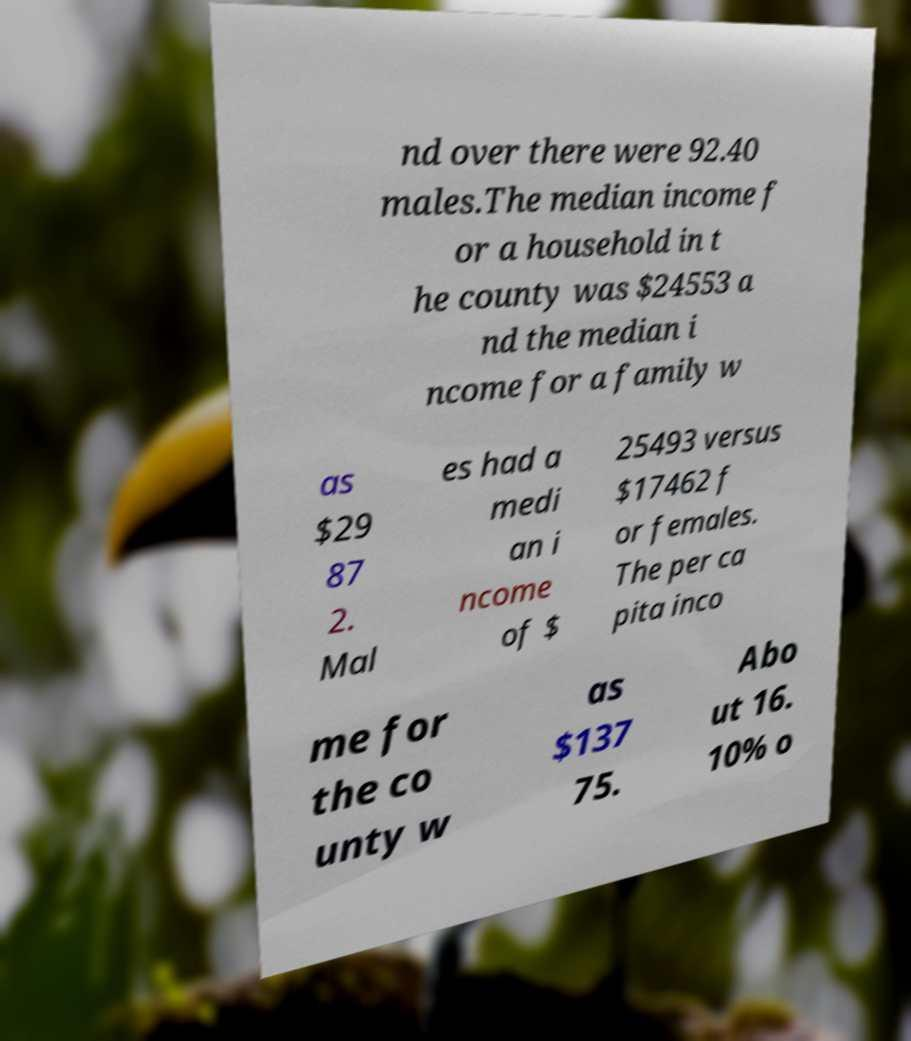Can you accurately transcribe the text from the provided image for me? nd over there were 92.40 males.The median income f or a household in t he county was $24553 a nd the median i ncome for a family w as $29 87 2. Mal es had a medi an i ncome of $ 25493 versus $17462 f or females. The per ca pita inco me for the co unty w as $137 75. Abo ut 16. 10% o 